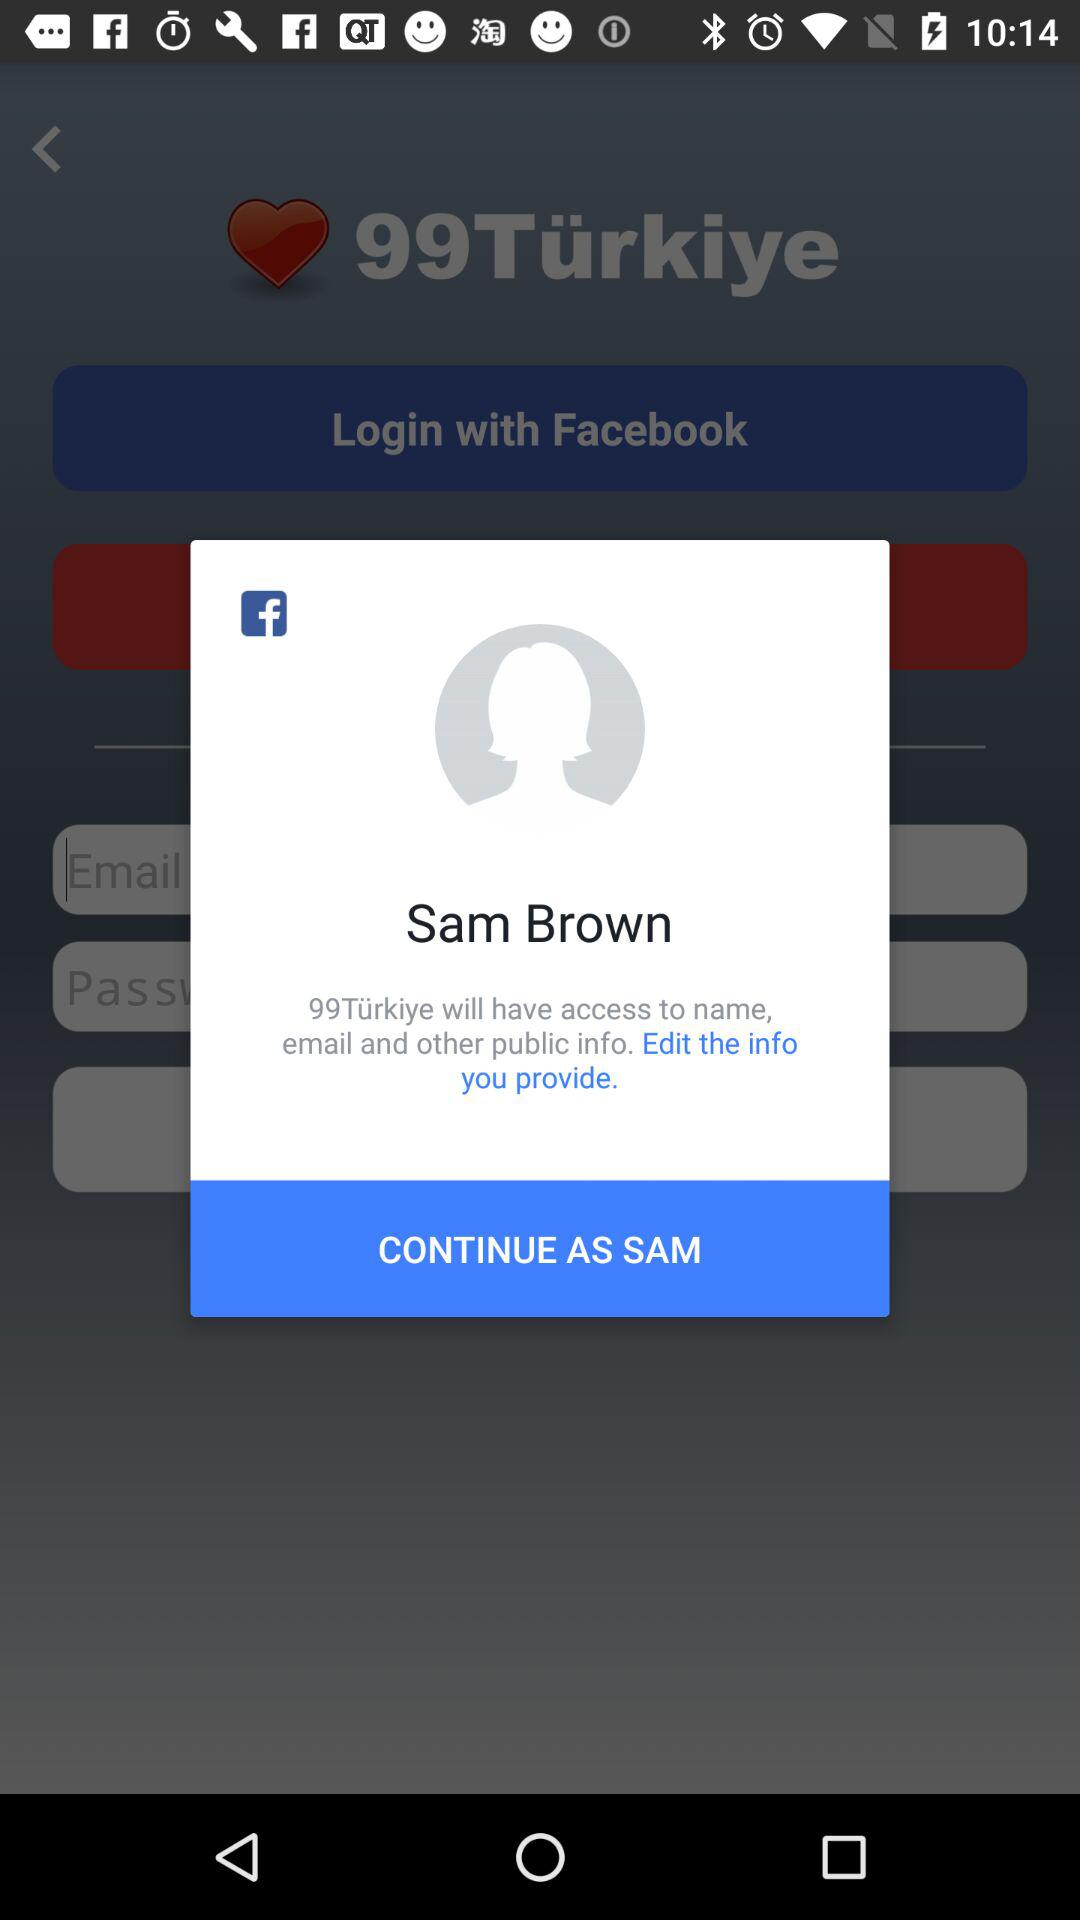What's the user profile name? The user profile name is Sam Brown. 